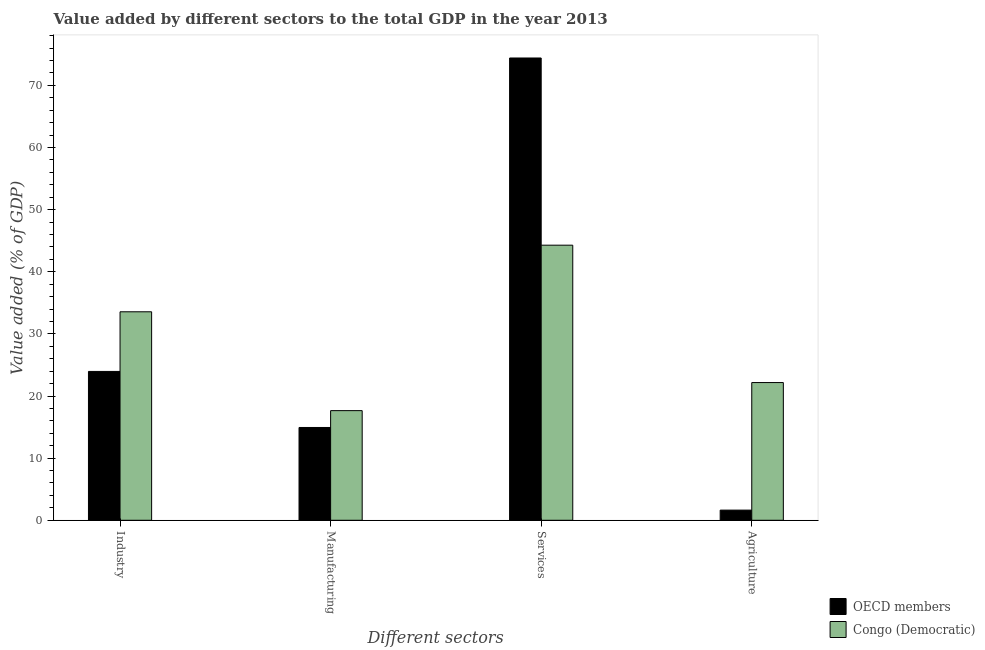How many different coloured bars are there?
Ensure brevity in your answer.  2. Are the number of bars per tick equal to the number of legend labels?
Provide a short and direct response. Yes. Are the number of bars on each tick of the X-axis equal?
Your response must be concise. Yes. How many bars are there on the 4th tick from the left?
Give a very brief answer. 2. What is the label of the 3rd group of bars from the left?
Give a very brief answer. Services. What is the value added by agricultural sector in Congo (Democratic)?
Keep it short and to the point. 22.17. Across all countries, what is the maximum value added by agricultural sector?
Give a very brief answer. 22.17. Across all countries, what is the minimum value added by services sector?
Ensure brevity in your answer.  44.28. In which country was the value added by manufacturing sector maximum?
Provide a succinct answer. Congo (Democratic). What is the total value added by agricultural sector in the graph?
Your response must be concise. 23.8. What is the difference between the value added by industrial sector in OECD members and that in Congo (Democratic)?
Provide a short and direct response. -9.6. What is the difference between the value added by industrial sector in Congo (Democratic) and the value added by services sector in OECD members?
Provide a succinct answer. -40.85. What is the average value added by services sector per country?
Your response must be concise. 59.34. What is the difference between the value added by manufacturing sector and value added by agricultural sector in OECD members?
Keep it short and to the point. 13.3. What is the ratio of the value added by manufacturing sector in Congo (Democratic) to that in OECD members?
Offer a very short reply. 1.18. Is the value added by services sector in Congo (Democratic) less than that in OECD members?
Provide a short and direct response. Yes. Is the difference between the value added by agricultural sector in OECD members and Congo (Democratic) greater than the difference between the value added by industrial sector in OECD members and Congo (Democratic)?
Keep it short and to the point. No. What is the difference between the highest and the second highest value added by agricultural sector?
Provide a short and direct response. 20.53. What is the difference between the highest and the lowest value added by agricultural sector?
Offer a terse response. 20.53. Is the sum of the value added by industrial sector in Congo (Democratic) and OECD members greater than the maximum value added by agricultural sector across all countries?
Give a very brief answer. Yes. Is it the case that in every country, the sum of the value added by services sector and value added by manufacturing sector is greater than the sum of value added by agricultural sector and value added by industrial sector?
Offer a terse response. Yes. What does the 2nd bar from the left in Agriculture represents?
Provide a succinct answer. Congo (Democratic). What does the 2nd bar from the right in Industry represents?
Provide a short and direct response. OECD members. Is it the case that in every country, the sum of the value added by industrial sector and value added by manufacturing sector is greater than the value added by services sector?
Your answer should be very brief. No. How many bars are there?
Keep it short and to the point. 8. Are all the bars in the graph horizontal?
Provide a short and direct response. No. What is the difference between two consecutive major ticks on the Y-axis?
Give a very brief answer. 10. Does the graph contain any zero values?
Keep it short and to the point. No. Does the graph contain grids?
Offer a very short reply. No. How are the legend labels stacked?
Provide a short and direct response. Vertical. What is the title of the graph?
Offer a very short reply. Value added by different sectors to the total GDP in the year 2013. What is the label or title of the X-axis?
Provide a short and direct response. Different sectors. What is the label or title of the Y-axis?
Offer a very short reply. Value added (% of GDP). What is the Value added (% of GDP) in OECD members in Industry?
Make the answer very short. 23.96. What is the Value added (% of GDP) of Congo (Democratic) in Industry?
Keep it short and to the point. 33.56. What is the Value added (% of GDP) of OECD members in Manufacturing?
Your response must be concise. 14.94. What is the Value added (% of GDP) in Congo (Democratic) in Manufacturing?
Provide a short and direct response. 17.65. What is the Value added (% of GDP) in OECD members in Services?
Provide a succinct answer. 74.41. What is the Value added (% of GDP) in Congo (Democratic) in Services?
Your response must be concise. 44.28. What is the Value added (% of GDP) in OECD members in Agriculture?
Keep it short and to the point. 1.63. What is the Value added (% of GDP) of Congo (Democratic) in Agriculture?
Ensure brevity in your answer.  22.17. Across all Different sectors, what is the maximum Value added (% of GDP) in OECD members?
Give a very brief answer. 74.41. Across all Different sectors, what is the maximum Value added (% of GDP) in Congo (Democratic)?
Keep it short and to the point. 44.28. Across all Different sectors, what is the minimum Value added (% of GDP) in OECD members?
Offer a terse response. 1.63. Across all Different sectors, what is the minimum Value added (% of GDP) of Congo (Democratic)?
Provide a succinct answer. 17.65. What is the total Value added (% of GDP) of OECD members in the graph?
Offer a terse response. 114.94. What is the total Value added (% of GDP) in Congo (Democratic) in the graph?
Your answer should be very brief. 117.65. What is the difference between the Value added (% of GDP) in OECD members in Industry and that in Manufacturing?
Ensure brevity in your answer.  9.02. What is the difference between the Value added (% of GDP) in Congo (Democratic) in Industry and that in Manufacturing?
Keep it short and to the point. 15.91. What is the difference between the Value added (% of GDP) of OECD members in Industry and that in Services?
Provide a succinct answer. -50.45. What is the difference between the Value added (% of GDP) in Congo (Democratic) in Industry and that in Services?
Ensure brevity in your answer.  -10.72. What is the difference between the Value added (% of GDP) of OECD members in Industry and that in Agriculture?
Give a very brief answer. 22.32. What is the difference between the Value added (% of GDP) in Congo (Democratic) in Industry and that in Agriculture?
Give a very brief answer. 11.39. What is the difference between the Value added (% of GDP) in OECD members in Manufacturing and that in Services?
Your answer should be very brief. -59.47. What is the difference between the Value added (% of GDP) of Congo (Democratic) in Manufacturing and that in Services?
Give a very brief answer. -26.63. What is the difference between the Value added (% of GDP) in OECD members in Manufacturing and that in Agriculture?
Ensure brevity in your answer.  13.3. What is the difference between the Value added (% of GDP) of Congo (Democratic) in Manufacturing and that in Agriculture?
Ensure brevity in your answer.  -4.52. What is the difference between the Value added (% of GDP) in OECD members in Services and that in Agriculture?
Give a very brief answer. 72.77. What is the difference between the Value added (% of GDP) of Congo (Democratic) in Services and that in Agriculture?
Ensure brevity in your answer.  22.11. What is the difference between the Value added (% of GDP) of OECD members in Industry and the Value added (% of GDP) of Congo (Democratic) in Manufacturing?
Your answer should be compact. 6.31. What is the difference between the Value added (% of GDP) in OECD members in Industry and the Value added (% of GDP) in Congo (Democratic) in Services?
Your response must be concise. -20.32. What is the difference between the Value added (% of GDP) of OECD members in Industry and the Value added (% of GDP) of Congo (Democratic) in Agriculture?
Your response must be concise. 1.79. What is the difference between the Value added (% of GDP) in OECD members in Manufacturing and the Value added (% of GDP) in Congo (Democratic) in Services?
Your answer should be compact. -29.34. What is the difference between the Value added (% of GDP) of OECD members in Manufacturing and the Value added (% of GDP) of Congo (Democratic) in Agriculture?
Keep it short and to the point. -7.23. What is the difference between the Value added (% of GDP) of OECD members in Services and the Value added (% of GDP) of Congo (Democratic) in Agriculture?
Offer a very short reply. 52.24. What is the average Value added (% of GDP) in OECD members per Different sectors?
Offer a terse response. 28.73. What is the average Value added (% of GDP) in Congo (Democratic) per Different sectors?
Your answer should be very brief. 29.41. What is the difference between the Value added (% of GDP) in OECD members and Value added (% of GDP) in Congo (Democratic) in Industry?
Ensure brevity in your answer.  -9.6. What is the difference between the Value added (% of GDP) in OECD members and Value added (% of GDP) in Congo (Democratic) in Manufacturing?
Keep it short and to the point. -2.71. What is the difference between the Value added (% of GDP) in OECD members and Value added (% of GDP) in Congo (Democratic) in Services?
Offer a very short reply. 30.13. What is the difference between the Value added (% of GDP) in OECD members and Value added (% of GDP) in Congo (Democratic) in Agriculture?
Make the answer very short. -20.53. What is the ratio of the Value added (% of GDP) in OECD members in Industry to that in Manufacturing?
Give a very brief answer. 1.6. What is the ratio of the Value added (% of GDP) of Congo (Democratic) in Industry to that in Manufacturing?
Provide a short and direct response. 1.9. What is the ratio of the Value added (% of GDP) of OECD members in Industry to that in Services?
Your answer should be compact. 0.32. What is the ratio of the Value added (% of GDP) in Congo (Democratic) in Industry to that in Services?
Your answer should be compact. 0.76. What is the ratio of the Value added (% of GDP) of OECD members in Industry to that in Agriculture?
Your answer should be very brief. 14.66. What is the ratio of the Value added (% of GDP) in Congo (Democratic) in Industry to that in Agriculture?
Your response must be concise. 1.51. What is the ratio of the Value added (% of GDP) in OECD members in Manufacturing to that in Services?
Offer a very short reply. 0.2. What is the ratio of the Value added (% of GDP) of Congo (Democratic) in Manufacturing to that in Services?
Provide a succinct answer. 0.4. What is the ratio of the Value added (% of GDP) of OECD members in Manufacturing to that in Agriculture?
Offer a terse response. 9.14. What is the ratio of the Value added (% of GDP) in Congo (Democratic) in Manufacturing to that in Agriculture?
Provide a succinct answer. 0.8. What is the ratio of the Value added (% of GDP) of OECD members in Services to that in Agriculture?
Offer a terse response. 45.52. What is the ratio of the Value added (% of GDP) in Congo (Democratic) in Services to that in Agriculture?
Your response must be concise. 2. What is the difference between the highest and the second highest Value added (% of GDP) in OECD members?
Offer a terse response. 50.45. What is the difference between the highest and the second highest Value added (% of GDP) of Congo (Democratic)?
Your answer should be compact. 10.72. What is the difference between the highest and the lowest Value added (% of GDP) in OECD members?
Your response must be concise. 72.77. What is the difference between the highest and the lowest Value added (% of GDP) of Congo (Democratic)?
Offer a terse response. 26.63. 